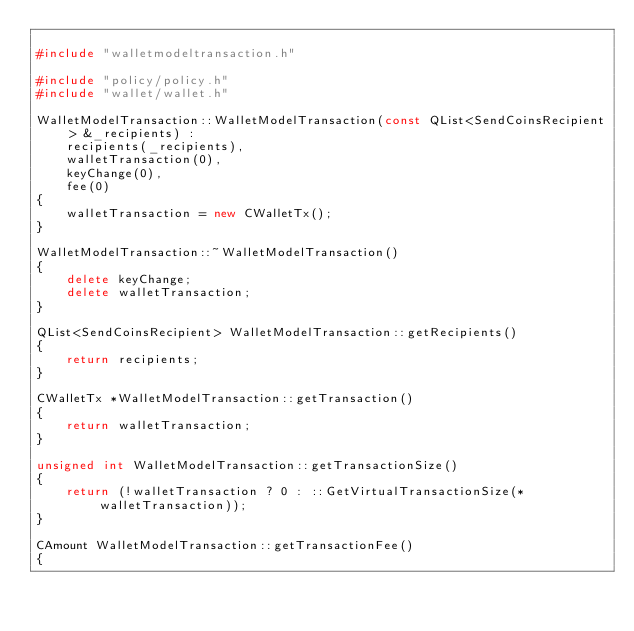<code> <loc_0><loc_0><loc_500><loc_500><_C++_>
#include "walletmodeltransaction.h"

#include "policy/policy.h"
#include "wallet/wallet.h"

WalletModelTransaction::WalletModelTransaction(const QList<SendCoinsRecipient> &_recipients) :
    recipients(_recipients),
    walletTransaction(0),
    keyChange(0),
    fee(0)
{
    walletTransaction = new CWalletTx();
}

WalletModelTransaction::~WalletModelTransaction()
{
    delete keyChange;
    delete walletTransaction;
}

QList<SendCoinsRecipient> WalletModelTransaction::getRecipients()
{
    return recipients;
}

CWalletTx *WalletModelTransaction::getTransaction()
{
    return walletTransaction;
}

unsigned int WalletModelTransaction::getTransactionSize()
{
    return (!walletTransaction ? 0 : ::GetVirtualTransactionSize(*walletTransaction));
}

CAmount WalletModelTransaction::getTransactionFee()
{</code> 